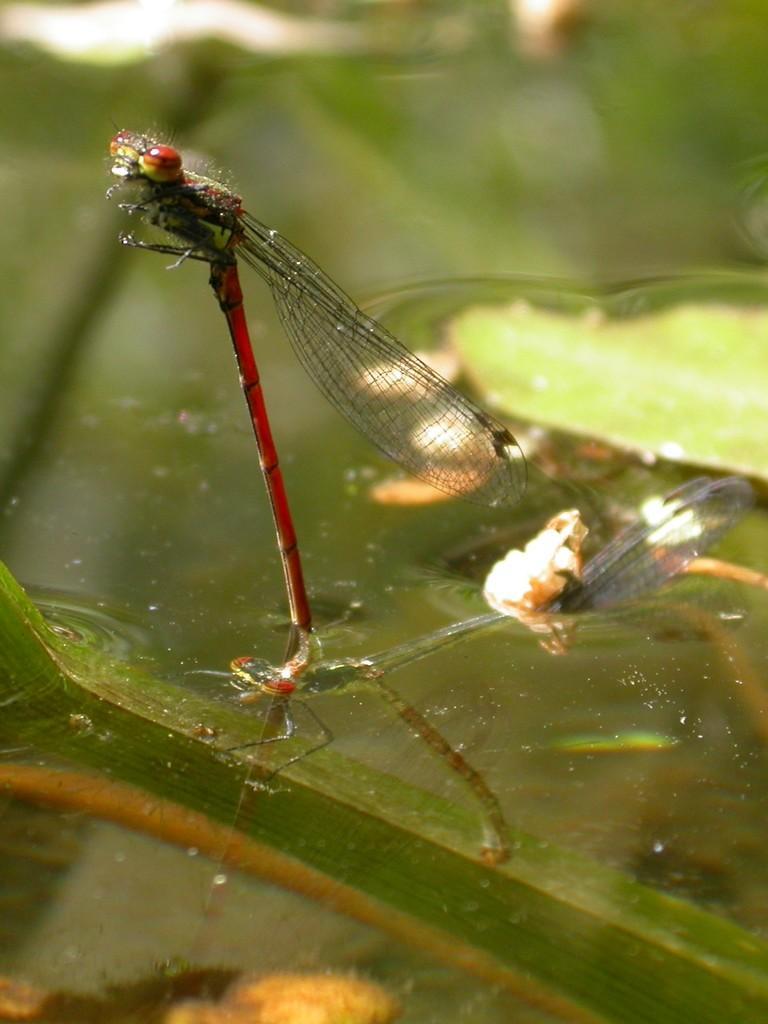Can you describe this image briefly? In this image there are flies on the surface of the water. Beside them there are lotus leaves. 